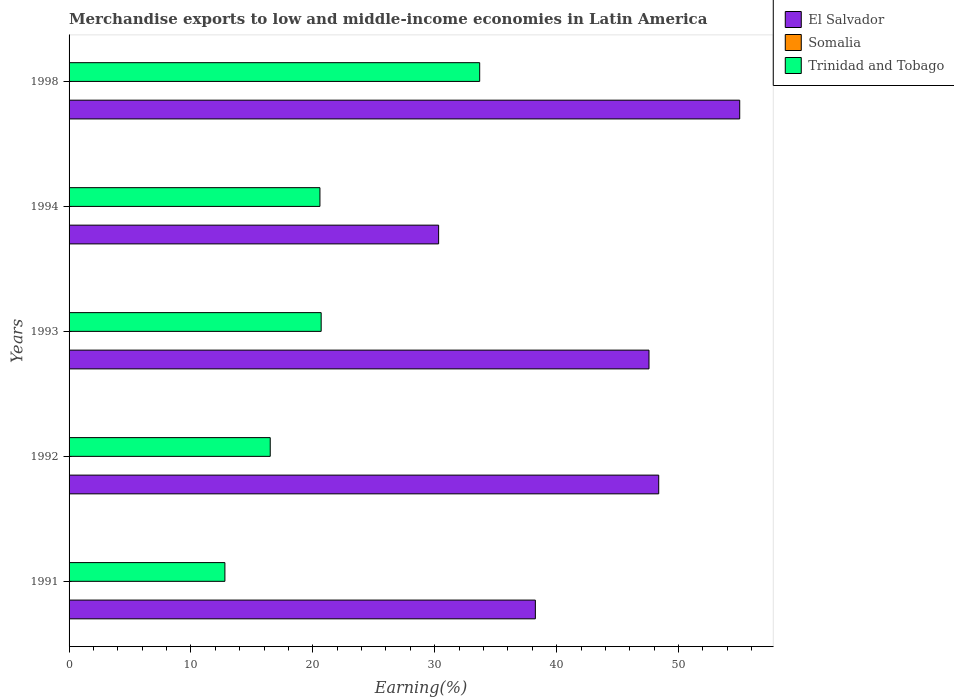How many groups of bars are there?
Provide a succinct answer. 5. Are the number of bars per tick equal to the number of legend labels?
Your answer should be compact. Yes. Are the number of bars on each tick of the Y-axis equal?
Provide a succinct answer. Yes. What is the label of the 2nd group of bars from the top?
Ensure brevity in your answer.  1994. In how many cases, is the number of bars for a given year not equal to the number of legend labels?
Offer a terse response. 0. What is the percentage of amount earned from merchandise exports in El Salvador in 1991?
Your answer should be compact. 38.25. Across all years, what is the maximum percentage of amount earned from merchandise exports in Trinidad and Tobago?
Your answer should be compact. 33.69. Across all years, what is the minimum percentage of amount earned from merchandise exports in El Salvador?
Keep it short and to the point. 30.32. In which year was the percentage of amount earned from merchandise exports in El Salvador maximum?
Offer a terse response. 1998. In which year was the percentage of amount earned from merchandise exports in Somalia minimum?
Your response must be concise. 1991. What is the total percentage of amount earned from merchandise exports in Somalia in the graph?
Your answer should be very brief. 0.06. What is the difference between the percentage of amount earned from merchandise exports in Trinidad and Tobago in 1993 and that in 1998?
Keep it short and to the point. -13. What is the difference between the percentage of amount earned from merchandise exports in El Salvador in 1994 and the percentage of amount earned from merchandise exports in Trinidad and Tobago in 1991?
Ensure brevity in your answer.  17.53. What is the average percentage of amount earned from merchandise exports in Trinidad and Tobago per year?
Your answer should be very brief. 20.85. In the year 1994, what is the difference between the percentage of amount earned from merchandise exports in El Salvador and percentage of amount earned from merchandise exports in Trinidad and Tobago?
Ensure brevity in your answer.  9.74. In how many years, is the percentage of amount earned from merchandise exports in Trinidad and Tobago greater than 42 %?
Your answer should be very brief. 0. What is the ratio of the percentage of amount earned from merchandise exports in Trinidad and Tobago in 1993 to that in 1994?
Make the answer very short. 1. Is the percentage of amount earned from merchandise exports in El Salvador in 1991 less than that in 1993?
Ensure brevity in your answer.  Yes. What is the difference between the highest and the second highest percentage of amount earned from merchandise exports in Somalia?
Offer a terse response. 0.02. What is the difference between the highest and the lowest percentage of amount earned from merchandise exports in Somalia?
Make the answer very short. 0.03. In how many years, is the percentage of amount earned from merchandise exports in Trinidad and Tobago greater than the average percentage of amount earned from merchandise exports in Trinidad and Tobago taken over all years?
Keep it short and to the point. 1. Is the sum of the percentage of amount earned from merchandise exports in Trinidad and Tobago in 1992 and 1993 greater than the maximum percentage of amount earned from merchandise exports in Somalia across all years?
Make the answer very short. Yes. What does the 2nd bar from the top in 1998 represents?
Make the answer very short. Somalia. What does the 1st bar from the bottom in 1992 represents?
Offer a terse response. El Salvador. Is it the case that in every year, the sum of the percentage of amount earned from merchandise exports in El Salvador and percentage of amount earned from merchandise exports in Trinidad and Tobago is greater than the percentage of amount earned from merchandise exports in Somalia?
Your answer should be compact. Yes. Are all the bars in the graph horizontal?
Make the answer very short. Yes. Does the graph contain grids?
Keep it short and to the point. No. What is the title of the graph?
Offer a terse response. Merchandise exports to low and middle-income economies in Latin America. Does "Togo" appear as one of the legend labels in the graph?
Offer a terse response. No. What is the label or title of the X-axis?
Give a very brief answer. Earning(%). What is the label or title of the Y-axis?
Ensure brevity in your answer.  Years. What is the Earning(%) of El Salvador in 1991?
Make the answer very short. 38.25. What is the Earning(%) in Somalia in 1991?
Offer a very short reply. 0. What is the Earning(%) of Trinidad and Tobago in 1991?
Your answer should be very brief. 12.78. What is the Earning(%) in El Salvador in 1992?
Your answer should be very brief. 48.37. What is the Earning(%) in Somalia in 1992?
Ensure brevity in your answer.  0.03. What is the Earning(%) in Trinidad and Tobago in 1992?
Make the answer very short. 16.5. What is the Earning(%) in El Salvador in 1993?
Give a very brief answer. 47.58. What is the Earning(%) in Somalia in 1993?
Offer a very short reply. 0.01. What is the Earning(%) of Trinidad and Tobago in 1993?
Ensure brevity in your answer.  20.68. What is the Earning(%) in El Salvador in 1994?
Your response must be concise. 30.32. What is the Earning(%) of Somalia in 1994?
Your answer should be compact. 0.02. What is the Earning(%) in Trinidad and Tobago in 1994?
Provide a succinct answer. 20.58. What is the Earning(%) of El Salvador in 1998?
Offer a terse response. 55.02. What is the Earning(%) in Somalia in 1998?
Offer a very short reply. 0. What is the Earning(%) of Trinidad and Tobago in 1998?
Give a very brief answer. 33.69. Across all years, what is the maximum Earning(%) in El Salvador?
Ensure brevity in your answer.  55.02. Across all years, what is the maximum Earning(%) of Somalia?
Your response must be concise. 0.03. Across all years, what is the maximum Earning(%) in Trinidad and Tobago?
Your answer should be compact. 33.69. Across all years, what is the minimum Earning(%) in El Salvador?
Provide a succinct answer. 30.32. Across all years, what is the minimum Earning(%) in Somalia?
Offer a terse response. 0. Across all years, what is the minimum Earning(%) in Trinidad and Tobago?
Ensure brevity in your answer.  12.78. What is the total Earning(%) of El Salvador in the graph?
Your response must be concise. 219.55. What is the total Earning(%) of Somalia in the graph?
Your response must be concise. 0.06. What is the total Earning(%) of Trinidad and Tobago in the graph?
Make the answer very short. 104.24. What is the difference between the Earning(%) of El Salvador in 1991 and that in 1992?
Your answer should be very brief. -10.12. What is the difference between the Earning(%) in Somalia in 1991 and that in 1992?
Your answer should be very brief. -0.03. What is the difference between the Earning(%) of Trinidad and Tobago in 1991 and that in 1992?
Keep it short and to the point. -3.72. What is the difference between the Earning(%) in El Salvador in 1991 and that in 1993?
Give a very brief answer. -9.32. What is the difference between the Earning(%) of Somalia in 1991 and that in 1993?
Give a very brief answer. -0.01. What is the difference between the Earning(%) in Trinidad and Tobago in 1991 and that in 1993?
Your response must be concise. -7.9. What is the difference between the Earning(%) in El Salvador in 1991 and that in 1994?
Provide a short and direct response. 7.94. What is the difference between the Earning(%) in Somalia in 1991 and that in 1994?
Provide a short and direct response. -0.01. What is the difference between the Earning(%) of Trinidad and Tobago in 1991 and that in 1994?
Your response must be concise. -7.8. What is the difference between the Earning(%) of El Salvador in 1991 and that in 1998?
Your response must be concise. -16.77. What is the difference between the Earning(%) of Somalia in 1991 and that in 1998?
Your answer should be compact. -0. What is the difference between the Earning(%) in Trinidad and Tobago in 1991 and that in 1998?
Make the answer very short. -20.9. What is the difference between the Earning(%) in El Salvador in 1992 and that in 1993?
Your answer should be very brief. 0.8. What is the difference between the Earning(%) of Somalia in 1992 and that in 1993?
Ensure brevity in your answer.  0.03. What is the difference between the Earning(%) of Trinidad and Tobago in 1992 and that in 1993?
Ensure brevity in your answer.  -4.18. What is the difference between the Earning(%) of El Salvador in 1992 and that in 1994?
Your answer should be very brief. 18.06. What is the difference between the Earning(%) in Somalia in 1992 and that in 1994?
Offer a very short reply. 0.02. What is the difference between the Earning(%) in Trinidad and Tobago in 1992 and that in 1994?
Make the answer very short. -4.08. What is the difference between the Earning(%) of El Salvador in 1992 and that in 1998?
Your answer should be very brief. -6.65. What is the difference between the Earning(%) of Somalia in 1992 and that in 1998?
Keep it short and to the point. 0.03. What is the difference between the Earning(%) in Trinidad and Tobago in 1992 and that in 1998?
Your response must be concise. -17.18. What is the difference between the Earning(%) of El Salvador in 1993 and that in 1994?
Provide a succinct answer. 17.26. What is the difference between the Earning(%) in Somalia in 1993 and that in 1994?
Your answer should be very brief. -0.01. What is the difference between the Earning(%) of Trinidad and Tobago in 1993 and that in 1994?
Offer a very short reply. 0.1. What is the difference between the Earning(%) in El Salvador in 1993 and that in 1998?
Make the answer very short. -7.44. What is the difference between the Earning(%) of Somalia in 1993 and that in 1998?
Your answer should be compact. 0.01. What is the difference between the Earning(%) of Trinidad and Tobago in 1993 and that in 1998?
Offer a very short reply. -13. What is the difference between the Earning(%) of El Salvador in 1994 and that in 1998?
Offer a terse response. -24.7. What is the difference between the Earning(%) in Somalia in 1994 and that in 1998?
Make the answer very short. 0.01. What is the difference between the Earning(%) in Trinidad and Tobago in 1994 and that in 1998?
Ensure brevity in your answer.  -13.11. What is the difference between the Earning(%) in El Salvador in 1991 and the Earning(%) in Somalia in 1992?
Ensure brevity in your answer.  38.22. What is the difference between the Earning(%) in El Salvador in 1991 and the Earning(%) in Trinidad and Tobago in 1992?
Offer a very short reply. 21.75. What is the difference between the Earning(%) in Somalia in 1991 and the Earning(%) in Trinidad and Tobago in 1992?
Your answer should be compact. -16.5. What is the difference between the Earning(%) in El Salvador in 1991 and the Earning(%) in Somalia in 1993?
Make the answer very short. 38.25. What is the difference between the Earning(%) in El Salvador in 1991 and the Earning(%) in Trinidad and Tobago in 1993?
Give a very brief answer. 17.57. What is the difference between the Earning(%) in Somalia in 1991 and the Earning(%) in Trinidad and Tobago in 1993?
Ensure brevity in your answer.  -20.68. What is the difference between the Earning(%) in El Salvador in 1991 and the Earning(%) in Somalia in 1994?
Your answer should be very brief. 38.24. What is the difference between the Earning(%) of El Salvador in 1991 and the Earning(%) of Trinidad and Tobago in 1994?
Make the answer very short. 17.67. What is the difference between the Earning(%) of Somalia in 1991 and the Earning(%) of Trinidad and Tobago in 1994?
Keep it short and to the point. -20.58. What is the difference between the Earning(%) in El Salvador in 1991 and the Earning(%) in Somalia in 1998?
Your answer should be compact. 38.25. What is the difference between the Earning(%) in El Salvador in 1991 and the Earning(%) in Trinidad and Tobago in 1998?
Your response must be concise. 4.57. What is the difference between the Earning(%) in Somalia in 1991 and the Earning(%) in Trinidad and Tobago in 1998?
Your answer should be compact. -33.69. What is the difference between the Earning(%) of El Salvador in 1992 and the Earning(%) of Somalia in 1993?
Ensure brevity in your answer.  48.37. What is the difference between the Earning(%) of El Salvador in 1992 and the Earning(%) of Trinidad and Tobago in 1993?
Your answer should be very brief. 27.69. What is the difference between the Earning(%) of Somalia in 1992 and the Earning(%) of Trinidad and Tobago in 1993?
Provide a succinct answer. -20.65. What is the difference between the Earning(%) of El Salvador in 1992 and the Earning(%) of Somalia in 1994?
Ensure brevity in your answer.  48.36. What is the difference between the Earning(%) of El Salvador in 1992 and the Earning(%) of Trinidad and Tobago in 1994?
Your answer should be very brief. 27.79. What is the difference between the Earning(%) in Somalia in 1992 and the Earning(%) in Trinidad and Tobago in 1994?
Your answer should be very brief. -20.55. What is the difference between the Earning(%) in El Salvador in 1992 and the Earning(%) in Somalia in 1998?
Keep it short and to the point. 48.37. What is the difference between the Earning(%) of El Salvador in 1992 and the Earning(%) of Trinidad and Tobago in 1998?
Your response must be concise. 14.69. What is the difference between the Earning(%) in Somalia in 1992 and the Earning(%) in Trinidad and Tobago in 1998?
Your answer should be very brief. -33.65. What is the difference between the Earning(%) of El Salvador in 1993 and the Earning(%) of Somalia in 1994?
Keep it short and to the point. 47.56. What is the difference between the Earning(%) in El Salvador in 1993 and the Earning(%) in Trinidad and Tobago in 1994?
Provide a short and direct response. 27. What is the difference between the Earning(%) in Somalia in 1993 and the Earning(%) in Trinidad and Tobago in 1994?
Keep it short and to the point. -20.57. What is the difference between the Earning(%) of El Salvador in 1993 and the Earning(%) of Somalia in 1998?
Offer a terse response. 47.58. What is the difference between the Earning(%) of El Salvador in 1993 and the Earning(%) of Trinidad and Tobago in 1998?
Make the answer very short. 13.89. What is the difference between the Earning(%) of Somalia in 1993 and the Earning(%) of Trinidad and Tobago in 1998?
Provide a succinct answer. -33.68. What is the difference between the Earning(%) in El Salvador in 1994 and the Earning(%) in Somalia in 1998?
Your answer should be very brief. 30.32. What is the difference between the Earning(%) in El Salvador in 1994 and the Earning(%) in Trinidad and Tobago in 1998?
Provide a short and direct response. -3.37. What is the difference between the Earning(%) in Somalia in 1994 and the Earning(%) in Trinidad and Tobago in 1998?
Make the answer very short. -33.67. What is the average Earning(%) in El Salvador per year?
Ensure brevity in your answer.  43.91. What is the average Earning(%) of Somalia per year?
Offer a very short reply. 0.01. What is the average Earning(%) in Trinidad and Tobago per year?
Provide a short and direct response. 20.85. In the year 1991, what is the difference between the Earning(%) in El Salvador and Earning(%) in Somalia?
Provide a short and direct response. 38.25. In the year 1991, what is the difference between the Earning(%) in El Salvador and Earning(%) in Trinidad and Tobago?
Your response must be concise. 25.47. In the year 1991, what is the difference between the Earning(%) in Somalia and Earning(%) in Trinidad and Tobago?
Provide a succinct answer. -12.78. In the year 1992, what is the difference between the Earning(%) of El Salvador and Earning(%) of Somalia?
Your response must be concise. 48.34. In the year 1992, what is the difference between the Earning(%) of El Salvador and Earning(%) of Trinidad and Tobago?
Your response must be concise. 31.87. In the year 1992, what is the difference between the Earning(%) of Somalia and Earning(%) of Trinidad and Tobago?
Keep it short and to the point. -16.47. In the year 1993, what is the difference between the Earning(%) of El Salvador and Earning(%) of Somalia?
Give a very brief answer. 47.57. In the year 1993, what is the difference between the Earning(%) of El Salvador and Earning(%) of Trinidad and Tobago?
Your response must be concise. 26.89. In the year 1993, what is the difference between the Earning(%) in Somalia and Earning(%) in Trinidad and Tobago?
Provide a succinct answer. -20.67. In the year 1994, what is the difference between the Earning(%) in El Salvador and Earning(%) in Somalia?
Provide a succinct answer. 30.3. In the year 1994, what is the difference between the Earning(%) of El Salvador and Earning(%) of Trinidad and Tobago?
Offer a very short reply. 9.74. In the year 1994, what is the difference between the Earning(%) of Somalia and Earning(%) of Trinidad and Tobago?
Your response must be concise. -20.56. In the year 1998, what is the difference between the Earning(%) of El Salvador and Earning(%) of Somalia?
Make the answer very short. 55.02. In the year 1998, what is the difference between the Earning(%) in El Salvador and Earning(%) in Trinidad and Tobago?
Provide a succinct answer. 21.33. In the year 1998, what is the difference between the Earning(%) of Somalia and Earning(%) of Trinidad and Tobago?
Your answer should be very brief. -33.68. What is the ratio of the Earning(%) of El Salvador in 1991 to that in 1992?
Provide a short and direct response. 0.79. What is the ratio of the Earning(%) of Somalia in 1991 to that in 1992?
Offer a terse response. 0.04. What is the ratio of the Earning(%) in Trinidad and Tobago in 1991 to that in 1992?
Your answer should be compact. 0.77. What is the ratio of the Earning(%) of El Salvador in 1991 to that in 1993?
Provide a short and direct response. 0.8. What is the ratio of the Earning(%) of Somalia in 1991 to that in 1993?
Your answer should be very brief. 0.16. What is the ratio of the Earning(%) of Trinidad and Tobago in 1991 to that in 1993?
Provide a short and direct response. 0.62. What is the ratio of the Earning(%) of El Salvador in 1991 to that in 1994?
Make the answer very short. 1.26. What is the ratio of the Earning(%) in Somalia in 1991 to that in 1994?
Make the answer very short. 0.09. What is the ratio of the Earning(%) in Trinidad and Tobago in 1991 to that in 1994?
Make the answer very short. 0.62. What is the ratio of the Earning(%) of El Salvador in 1991 to that in 1998?
Provide a succinct answer. 0.7. What is the ratio of the Earning(%) in Somalia in 1991 to that in 1998?
Ensure brevity in your answer.  0.65. What is the ratio of the Earning(%) of Trinidad and Tobago in 1991 to that in 1998?
Your answer should be compact. 0.38. What is the ratio of the Earning(%) in El Salvador in 1992 to that in 1993?
Give a very brief answer. 1.02. What is the ratio of the Earning(%) in Somalia in 1992 to that in 1993?
Provide a short and direct response. 4.01. What is the ratio of the Earning(%) of Trinidad and Tobago in 1992 to that in 1993?
Your response must be concise. 0.8. What is the ratio of the Earning(%) of El Salvador in 1992 to that in 1994?
Offer a very short reply. 1.6. What is the ratio of the Earning(%) in Somalia in 1992 to that in 1994?
Your answer should be compact. 2.21. What is the ratio of the Earning(%) of Trinidad and Tobago in 1992 to that in 1994?
Provide a succinct answer. 0.8. What is the ratio of the Earning(%) in El Salvador in 1992 to that in 1998?
Your answer should be compact. 0.88. What is the ratio of the Earning(%) in Somalia in 1992 to that in 1998?
Offer a terse response. 16.48. What is the ratio of the Earning(%) of Trinidad and Tobago in 1992 to that in 1998?
Give a very brief answer. 0.49. What is the ratio of the Earning(%) in El Salvador in 1993 to that in 1994?
Provide a short and direct response. 1.57. What is the ratio of the Earning(%) in Somalia in 1993 to that in 1994?
Your response must be concise. 0.55. What is the ratio of the Earning(%) of Trinidad and Tobago in 1993 to that in 1994?
Make the answer very short. 1. What is the ratio of the Earning(%) in El Salvador in 1993 to that in 1998?
Provide a succinct answer. 0.86. What is the ratio of the Earning(%) in Somalia in 1993 to that in 1998?
Your answer should be very brief. 4.11. What is the ratio of the Earning(%) of Trinidad and Tobago in 1993 to that in 1998?
Offer a very short reply. 0.61. What is the ratio of the Earning(%) in El Salvador in 1994 to that in 1998?
Your response must be concise. 0.55. What is the ratio of the Earning(%) in Somalia in 1994 to that in 1998?
Your answer should be very brief. 7.45. What is the ratio of the Earning(%) in Trinidad and Tobago in 1994 to that in 1998?
Offer a very short reply. 0.61. What is the difference between the highest and the second highest Earning(%) in El Salvador?
Provide a succinct answer. 6.65. What is the difference between the highest and the second highest Earning(%) in Somalia?
Provide a short and direct response. 0.02. What is the difference between the highest and the second highest Earning(%) in Trinidad and Tobago?
Keep it short and to the point. 13. What is the difference between the highest and the lowest Earning(%) in El Salvador?
Keep it short and to the point. 24.7. What is the difference between the highest and the lowest Earning(%) of Somalia?
Your answer should be compact. 0.03. What is the difference between the highest and the lowest Earning(%) in Trinidad and Tobago?
Keep it short and to the point. 20.9. 